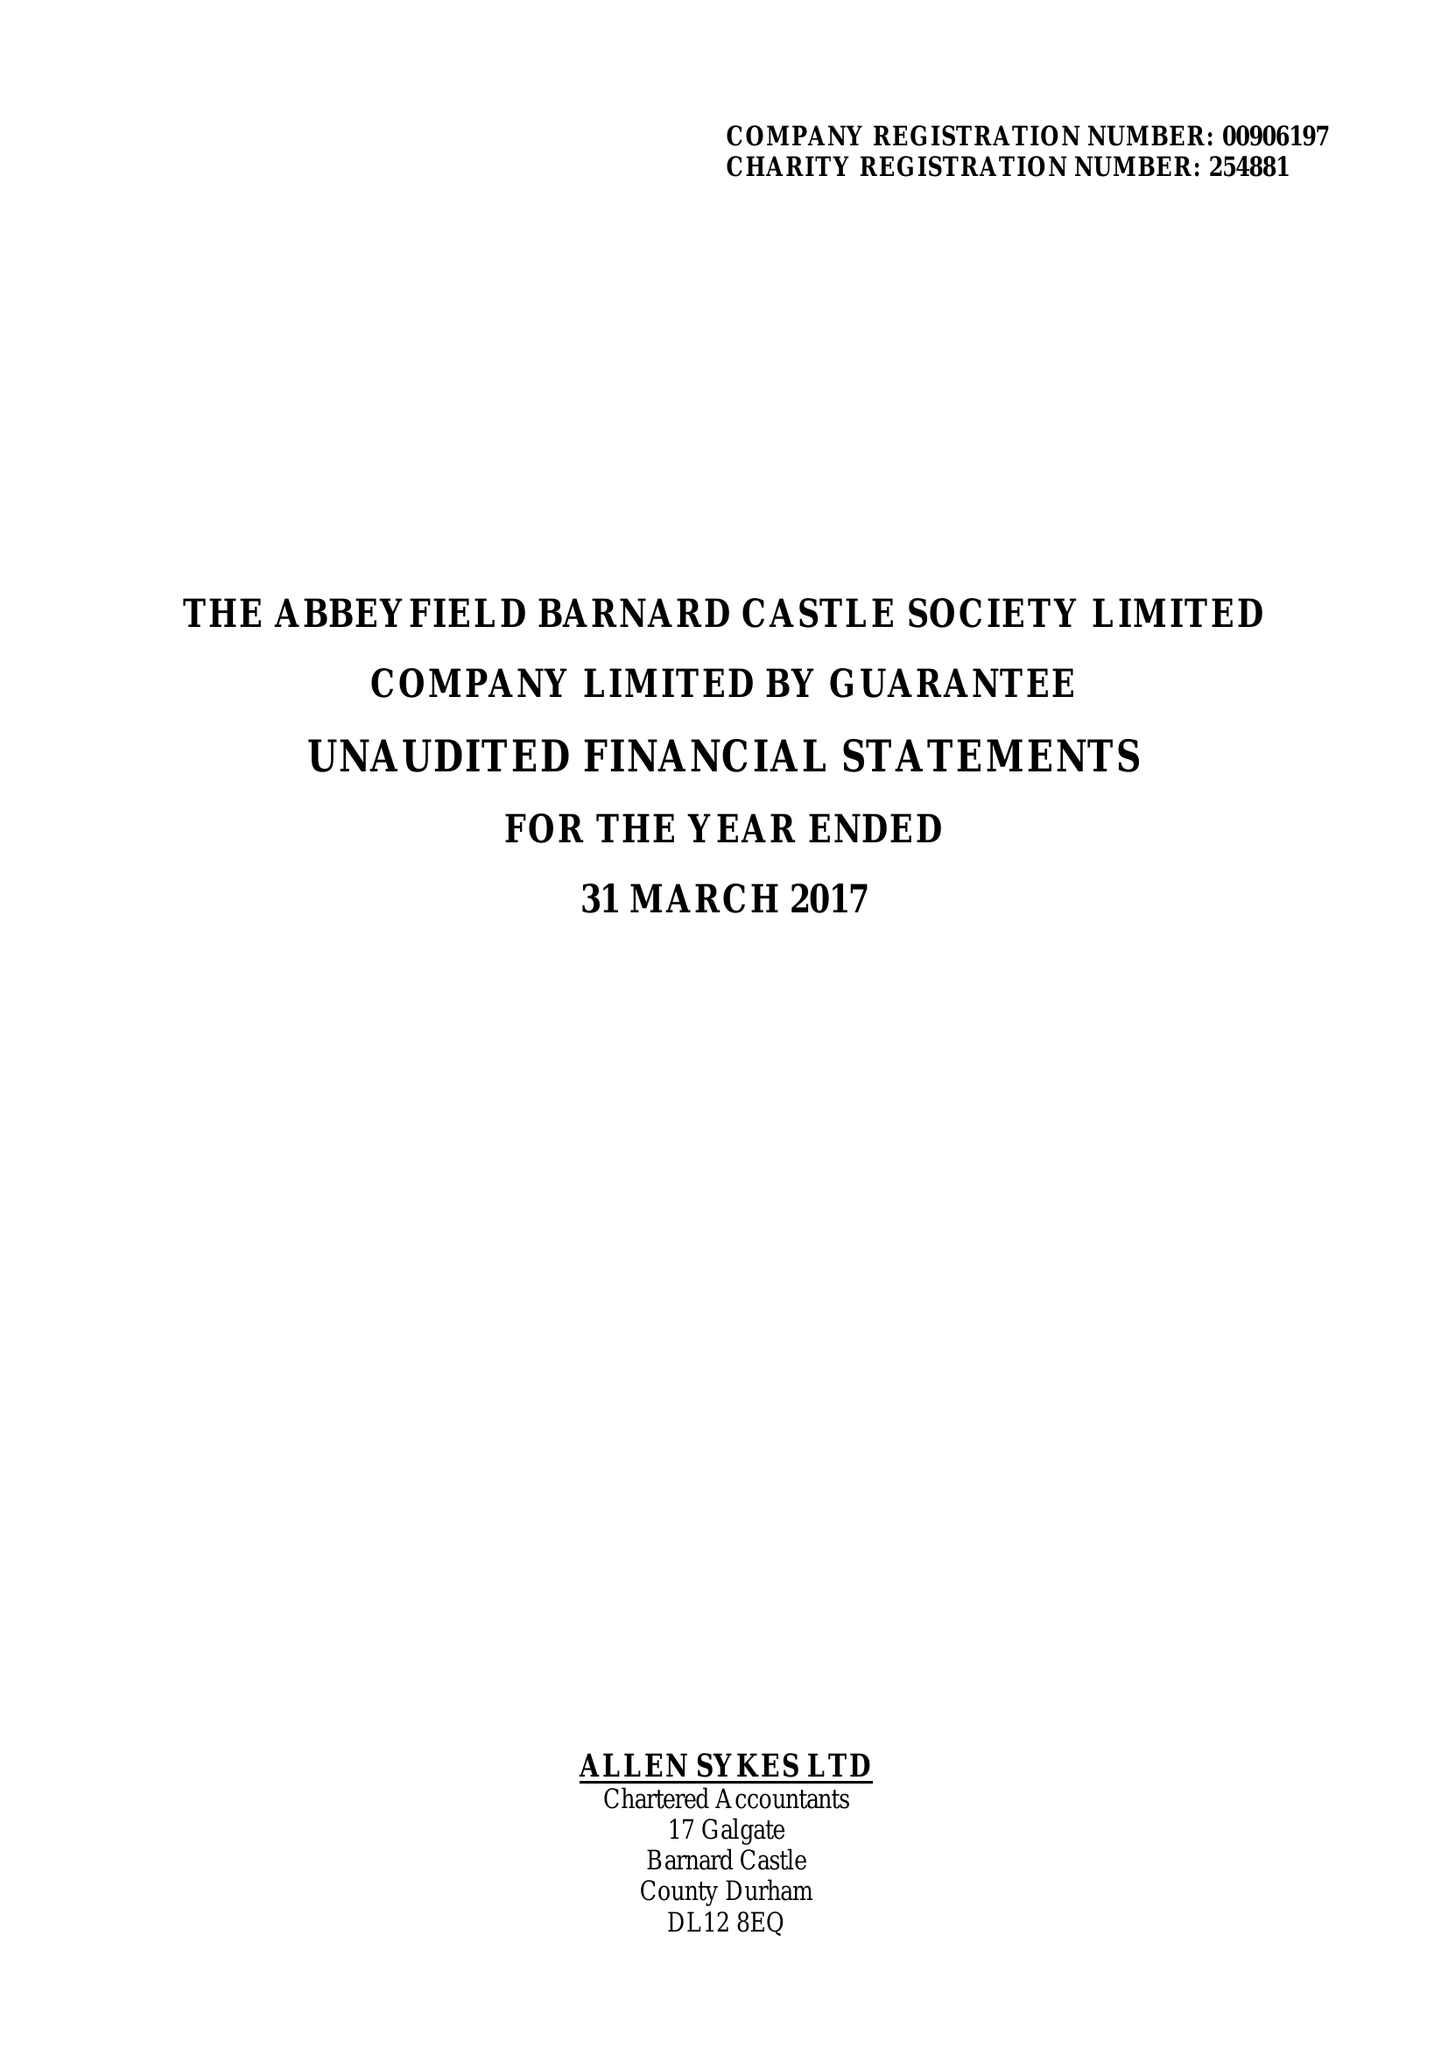What is the value for the address__street_line?
Answer the question using a single word or phrase. None 